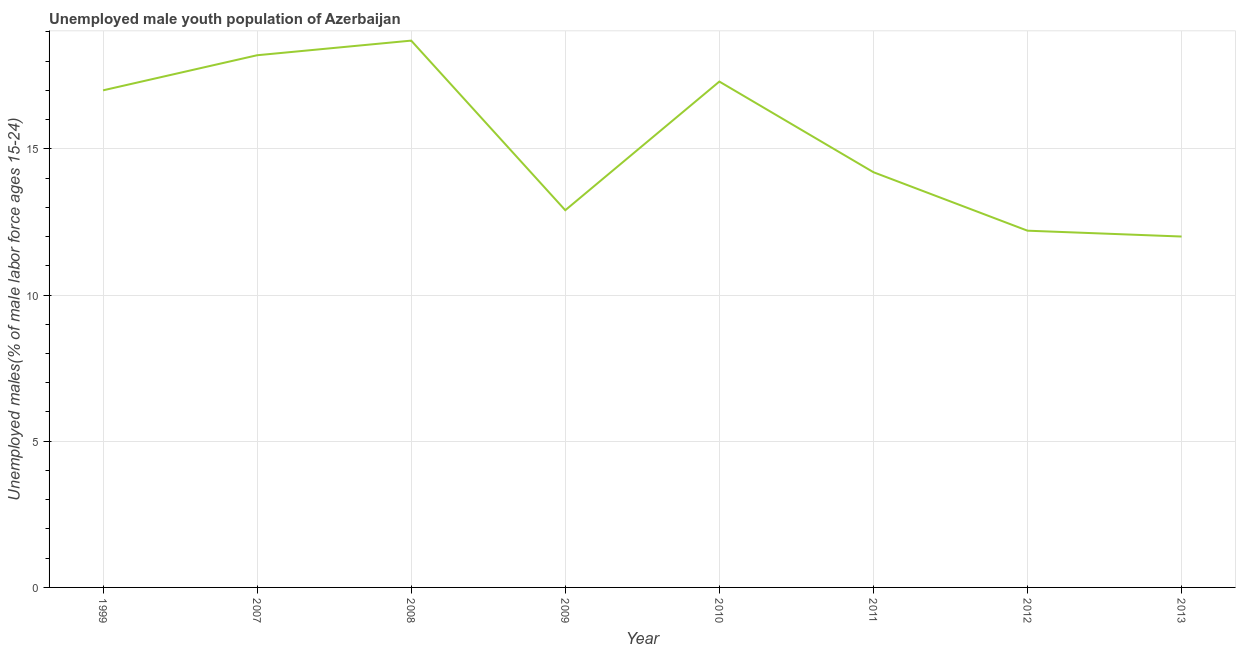What is the unemployed male youth in 2010?
Ensure brevity in your answer.  17.3. Across all years, what is the maximum unemployed male youth?
Your answer should be compact. 18.7. Across all years, what is the minimum unemployed male youth?
Your answer should be compact. 12. What is the sum of the unemployed male youth?
Your response must be concise. 122.5. What is the difference between the unemployed male youth in 2007 and 2012?
Offer a very short reply. 6. What is the average unemployed male youth per year?
Offer a terse response. 15.31. What is the median unemployed male youth?
Provide a succinct answer. 15.6. What is the ratio of the unemployed male youth in 1999 to that in 2007?
Your answer should be very brief. 0.93. Is the difference between the unemployed male youth in 2011 and 2012 greater than the difference between any two years?
Your answer should be very brief. No. What is the difference between the highest and the second highest unemployed male youth?
Offer a very short reply. 0.5. Is the sum of the unemployed male youth in 1999 and 2013 greater than the maximum unemployed male youth across all years?
Offer a very short reply. Yes. What is the difference between the highest and the lowest unemployed male youth?
Keep it short and to the point. 6.7. In how many years, is the unemployed male youth greater than the average unemployed male youth taken over all years?
Offer a terse response. 4. How many lines are there?
Offer a very short reply. 1. How many years are there in the graph?
Give a very brief answer. 8. What is the difference between two consecutive major ticks on the Y-axis?
Offer a terse response. 5. Does the graph contain grids?
Keep it short and to the point. Yes. What is the title of the graph?
Your answer should be compact. Unemployed male youth population of Azerbaijan. What is the label or title of the X-axis?
Your answer should be very brief. Year. What is the label or title of the Y-axis?
Provide a short and direct response. Unemployed males(% of male labor force ages 15-24). What is the Unemployed males(% of male labor force ages 15-24) in 2007?
Keep it short and to the point. 18.2. What is the Unemployed males(% of male labor force ages 15-24) of 2008?
Offer a very short reply. 18.7. What is the Unemployed males(% of male labor force ages 15-24) of 2009?
Keep it short and to the point. 12.9. What is the Unemployed males(% of male labor force ages 15-24) in 2010?
Offer a terse response. 17.3. What is the Unemployed males(% of male labor force ages 15-24) in 2011?
Your answer should be compact. 14.2. What is the Unemployed males(% of male labor force ages 15-24) of 2012?
Ensure brevity in your answer.  12.2. What is the difference between the Unemployed males(% of male labor force ages 15-24) in 1999 and 2007?
Offer a terse response. -1.2. What is the difference between the Unemployed males(% of male labor force ages 15-24) in 1999 and 2008?
Offer a terse response. -1.7. What is the difference between the Unemployed males(% of male labor force ages 15-24) in 1999 and 2009?
Make the answer very short. 4.1. What is the difference between the Unemployed males(% of male labor force ages 15-24) in 1999 and 2011?
Provide a succinct answer. 2.8. What is the difference between the Unemployed males(% of male labor force ages 15-24) in 1999 and 2013?
Keep it short and to the point. 5. What is the difference between the Unemployed males(% of male labor force ages 15-24) in 2007 and 2011?
Provide a succinct answer. 4. What is the difference between the Unemployed males(% of male labor force ages 15-24) in 2008 and 2009?
Provide a succinct answer. 5.8. What is the difference between the Unemployed males(% of male labor force ages 15-24) in 2008 and 2011?
Offer a terse response. 4.5. What is the difference between the Unemployed males(% of male labor force ages 15-24) in 2008 and 2012?
Ensure brevity in your answer.  6.5. What is the difference between the Unemployed males(% of male labor force ages 15-24) in 2009 and 2010?
Ensure brevity in your answer.  -4.4. What is the difference between the Unemployed males(% of male labor force ages 15-24) in 2009 and 2011?
Provide a short and direct response. -1.3. What is the difference between the Unemployed males(% of male labor force ages 15-24) in 2009 and 2012?
Offer a very short reply. 0.7. What is the difference between the Unemployed males(% of male labor force ages 15-24) in 2009 and 2013?
Provide a succinct answer. 0.9. What is the difference between the Unemployed males(% of male labor force ages 15-24) in 2010 and 2011?
Ensure brevity in your answer.  3.1. What is the difference between the Unemployed males(% of male labor force ages 15-24) in 2010 and 2012?
Ensure brevity in your answer.  5.1. What is the difference between the Unemployed males(% of male labor force ages 15-24) in 2011 and 2012?
Provide a succinct answer. 2. What is the difference between the Unemployed males(% of male labor force ages 15-24) in 2011 and 2013?
Provide a short and direct response. 2.2. What is the difference between the Unemployed males(% of male labor force ages 15-24) in 2012 and 2013?
Give a very brief answer. 0.2. What is the ratio of the Unemployed males(% of male labor force ages 15-24) in 1999 to that in 2007?
Provide a short and direct response. 0.93. What is the ratio of the Unemployed males(% of male labor force ages 15-24) in 1999 to that in 2008?
Offer a terse response. 0.91. What is the ratio of the Unemployed males(% of male labor force ages 15-24) in 1999 to that in 2009?
Give a very brief answer. 1.32. What is the ratio of the Unemployed males(% of male labor force ages 15-24) in 1999 to that in 2010?
Make the answer very short. 0.98. What is the ratio of the Unemployed males(% of male labor force ages 15-24) in 1999 to that in 2011?
Give a very brief answer. 1.2. What is the ratio of the Unemployed males(% of male labor force ages 15-24) in 1999 to that in 2012?
Keep it short and to the point. 1.39. What is the ratio of the Unemployed males(% of male labor force ages 15-24) in 1999 to that in 2013?
Keep it short and to the point. 1.42. What is the ratio of the Unemployed males(% of male labor force ages 15-24) in 2007 to that in 2008?
Provide a succinct answer. 0.97. What is the ratio of the Unemployed males(% of male labor force ages 15-24) in 2007 to that in 2009?
Offer a very short reply. 1.41. What is the ratio of the Unemployed males(% of male labor force ages 15-24) in 2007 to that in 2010?
Your answer should be compact. 1.05. What is the ratio of the Unemployed males(% of male labor force ages 15-24) in 2007 to that in 2011?
Your answer should be compact. 1.28. What is the ratio of the Unemployed males(% of male labor force ages 15-24) in 2007 to that in 2012?
Ensure brevity in your answer.  1.49. What is the ratio of the Unemployed males(% of male labor force ages 15-24) in 2007 to that in 2013?
Ensure brevity in your answer.  1.52. What is the ratio of the Unemployed males(% of male labor force ages 15-24) in 2008 to that in 2009?
Your answer should be very brief. 1.45. What is the ratio of the Unemployed males(% of male labor force ages 15-24) in 2008 to that in 2010?
Provide a succinct answer. 1.08. What is the ratio of the Unemployed males(% of male labor force ages 15-24) in 2008 to that in 2011?
Keep it short and to the point. 1.32. What is the ratio of the Unemployed males(% of male labor force ages 15-24) in 2008 to that in 2012?
Offer a very short reply. 1.53. What is the ratio of the Unemployed males(% of male labor force ages 15-24) in 2008 to that in 2013?
Your answer should be compact. 1.56. What is the ratio of the Unemployed males(% of male labor force ages 15-24) in 2009 to that in 2010?
Offer a terse response. 0.75. What is the ratio of the Unemployed males(% of male labor force ages 15-24) in 2009 to that in 2011?
Your response must be concise. 0.91. What is the ratio of the Unemployed males(% of male labor force ages 15-24) in 2009 to that in 2012?
Make the answer very short. 1.06. What is the ratio of the Unemployed males(% of male labor force ages 15-24) in 2009 to that in 2013?
Provide a succinct answer. 1.07. What is the ratio of the Unemployed males(% of male labor force ages 15-24) in 2010 to that in 2011?
Offer a terse response. 1.22. What is the ratio of the Unemployed males(% of male labor force ages 15-24) in 2010 to that in 2012?
Provide a succinct answer. 1.42. What is the ratio of the Unemployed males(% of male labor force ages 15-24) in 2010 to that in 2013?
Your answer should be very brief. 1.44. What is the ratio of the Unemployed males(% of male labor force ages 15-24) in 2011 to that in 2012?
Your response must be concise. 1.16. What is the ratio of the Unemployed males(% of male labor force ages 15-24) in 2011 to that in 2013?
Provide a succinct answer. 1.18. What is the ratio of the Unemployed males(% of male labor force ages 15-24) in 2012 to that in 2013?
Offer a very short reply. 1.02. 